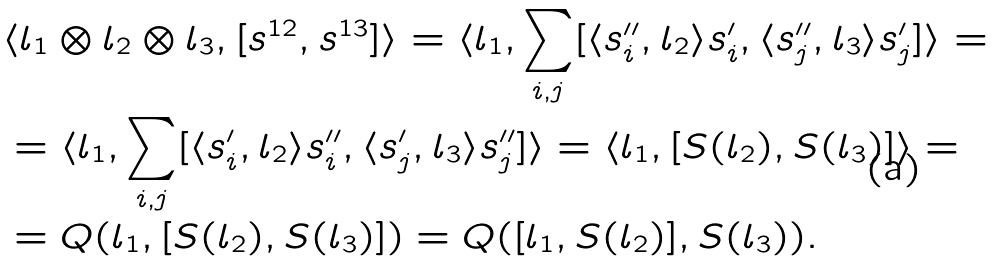<formula> <loc_0><loc_0><loc_500><loc_500>& \langle l _ { 1 } \otimes l _ { 2 } \otimes l _ { 3 } , [ s ^ { 1 2 } , s ^ { 1 3 } ] \rangle = \langle l _ { 1 } , \sum _ { i , j } [ \langle s _ { i } ^ { \prime \prime } , l _ { 2 } \rangle s _ { i } ^ { \prime } , \langle s _ { j } ^ { \prime \prime } , l _ { 3 } \rangle s _ { j } ^ { \prime } ] \rangle = \\ & = \langle l _ { 1 } , \sum _ { i , j } [ \langle s _ { i } ^ { \prime } , l _ { 2 } \rangle s _ { i } ^ { \prime \prime } , \langle s _ { j } ^ { \prime } , l _ { 3 } \rangle s _ { j } ^ { \prime \prime } ] \rangle = \langle l _ { 1 } , [ S ( l _ { 2 } ) , S ( l _ { 3 } ) ] \rangle = \\ & = Q ( l _ { 1 } , [ S ( l _ { 2 } ) , S ( l _ { 3 } ) ] ) = Q ( [ l _ { 1 } , S ( l _ { 2 } ) ] , S ( l _ { 3 } ) ) .</formula> 